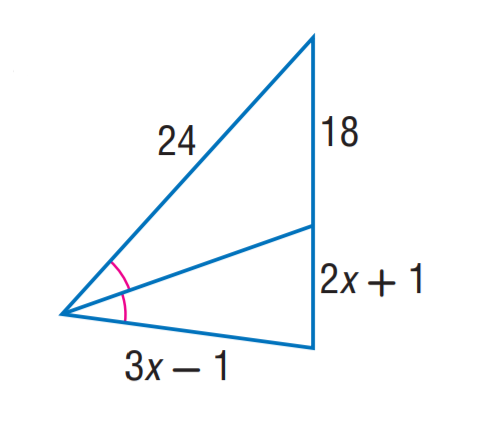Answer the mathemtical geometry problem and directly provide the correct option letter.
Question: Find x.
Choices: A: 5 B: 6 C: 7 D: 8 C 